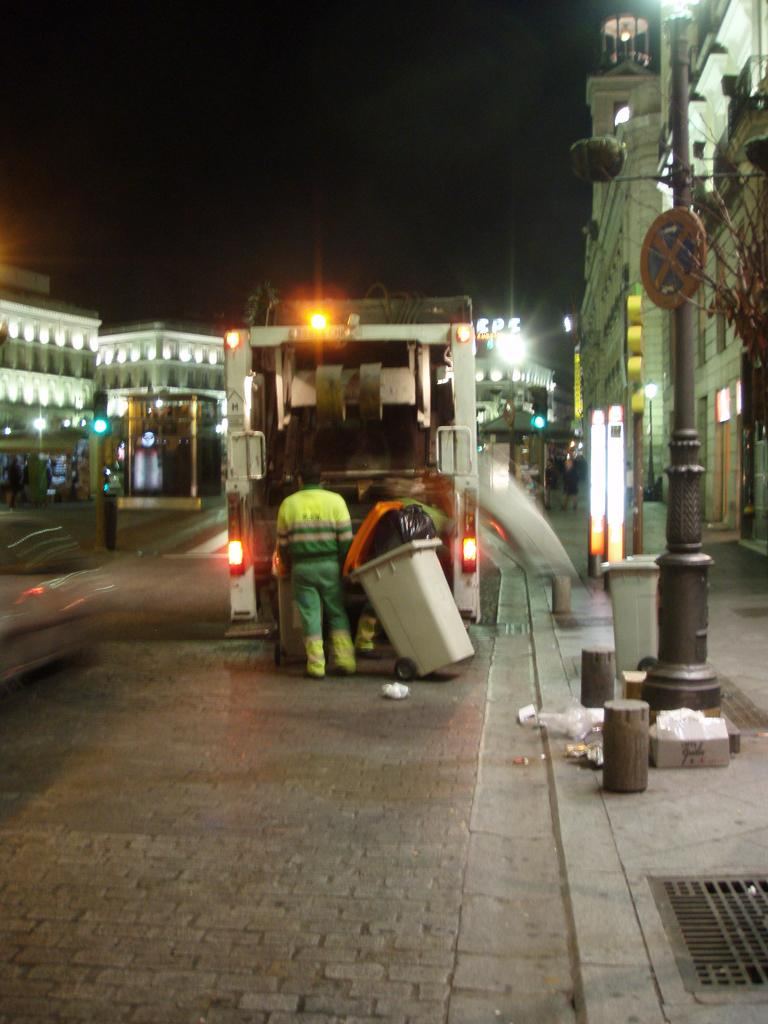What is the main feature of the image? There is a road in the image. What can be seen on the road? A man is standing on the road, and there is a van in front of him. What is located in front of the van? There is a dustbin in front of the van. What is visible on either side of the road? Buildings and poles are present on either side of the road. What discovery was made on the page in the image? There is no page present in the image; it features a road, a man, a van, a dustbin, buildings, and poles. 